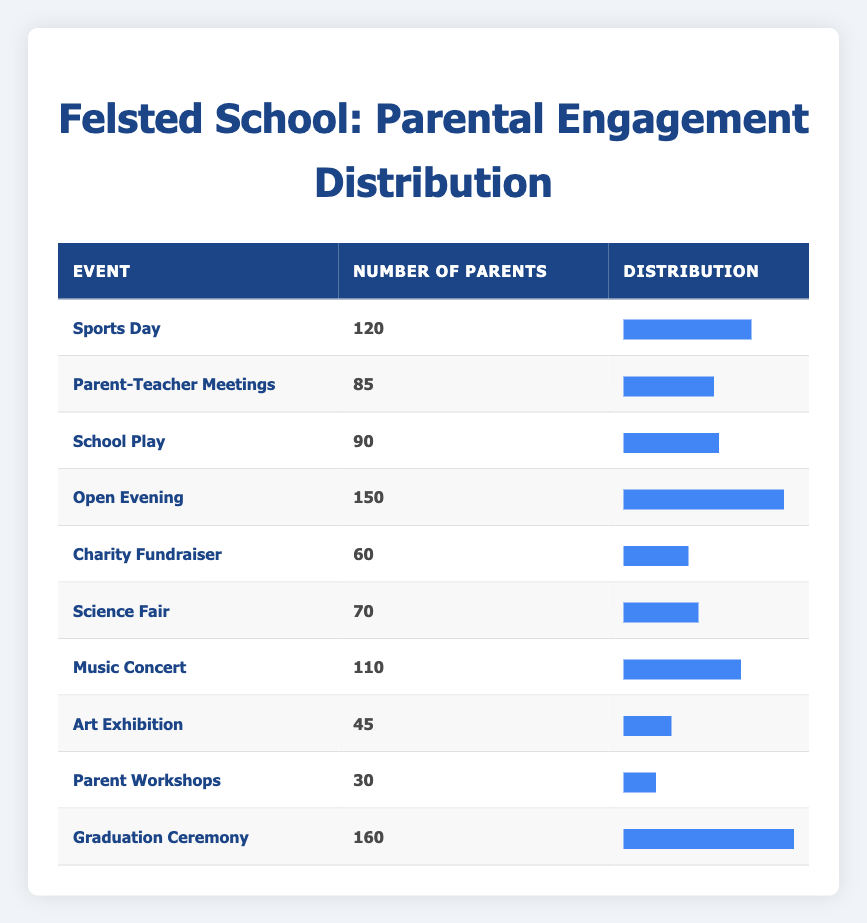What is the total number of parents that attended the Graduation Ceremony? The table indicates that 160 parents attended the Graduation Ceremony.
Answer: 160 How many parents attended the Open Evening? The number of parents that attended the Open Evening is 150, as shown in the table.
Answer: 150 Which event had the least parental engagement? The event with the least parental engagement is the Parent Workshops, with only 30 parents attending, which is the smallest number in the table.
Answer: 30 What is the difference in parental attendance between Sports Day and Parent-Teacher Meetings? Sports Day had 120 parents while Parent-Teacher Meetings had 85. The difference is calculated as 120 - 85 = 35.
Answer: 35 What percentage of parents attended the Music Concert compared to the Graduation Ceremony? To find the percentage, first calculate the attendance: Music Concert had 110 parents and Graduation Ceremony had 160. The percentage is (110 / 160) * 100 = 68.75%.
Answer: 68.75 Are more parents engaged in the Science Fair than in the Charity Fundraiser? According to the table, 70 parents attended the Science Fair while 60 attended the Charity Fundraiser. Since 70 is greater than 60, the answer is yes.
Answer: Yes Which event had more parental engagement: School Play or Music Concert? The School Play had 90 parents, and the Music Concert had 110 parents. Since 110 is greater than 90, the Music Concert had more engagement.
Answer: Music Concert What is the average number of parents attending the events listed in the table? To find the average, sum the number of parents across all events: 120 + 85 + 90 + 150 + 60 + 70 + 110 + 45 + 30 + 160 = 1,070 parents. There are 10 events, so the average is 1,070 / 10 = 107.
Answer: 107 What fraction of parents attended the Open Evening compared to the total number of parents across all events? Total number of parents across all events is 1,070. For Open Evening, 150 parents attended. Therefore, fraction = 150/1070, which simplifies to approximately 15/107.
Answer: 15/107 